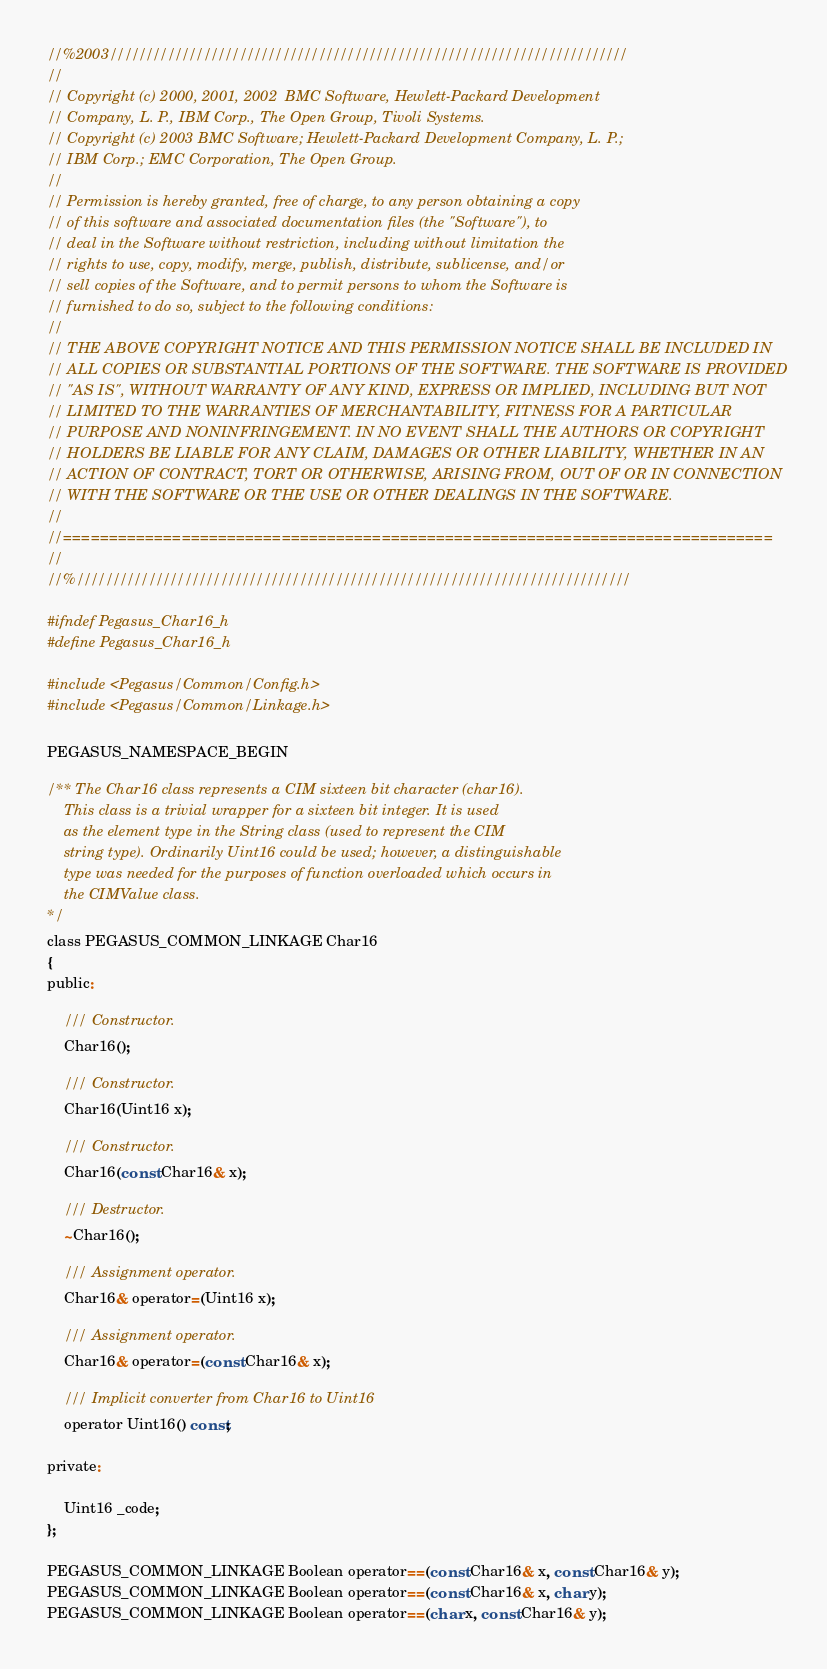Convert code to text. <code><loc_0><loc_0><loc_500><loc_500><_C_>//%2003////////////////////////////////////////////////////////////////////////
//
// Copyright (c) 2000, 2001, 2002  BMC Software, Hewlett-Packard Development
// Company, L. P., IBM Corp., The Open Group, Tivoli Systems.
// Copyright (c) 2003 BMC Software; Hewlett-Packard Development Company, L. P.;
// IBM Corp.; EMC Corporation, The Open Group.
//
// Permission is hereby granted, free of charge, to any person obtaining a copy
// of this software and associated documentation files (the "Software"), to
// deal in the Software without restriction, including without limitation the
// rights to use, copy, modify, merge, publish, distribute, sublicense, and/or
// sell copies of the Software, and to permit persons to whom the Software is
// furnished to do so, subject to the following conditions:
// 
// THE ABOVE COPYRIGHT NOTICE AND THIS PERMISSION NOTICE SHALL BE INCLUDED IN
// ALL COPIES OR SUBSTANTIAL PORTIONS OF THE SOFTWARE. THE SOFTWARE IS PROVIDED
// "AS IS", WITHOUT WARRANTY OF ANY KIND, EXPRESS OR IMPLIED, INCLUDING BUT NOT
// LIMITED TO THE WARRANTIES OF MERCHANTABILITY, FITNESS FOR A PARTICULAR
// PURPOSE AND NONINFRINGEMENT. IN NO EVENT SHALL THE AUTHORS OR COPYRIGHT
// HOLDERS BE LIABLE FOR ANY CLAIM, DAMAGES OR OTHER LIABILITY, WHETHER IN AN
// ACTION OF CONTRACT, TORT OR OTHERWISE, ARISING FROM, OUT OF OR IN CONNECTION
// WITH THE SOFTWARE OR THE USE OR OTHER DEALINGS IN THE SOFTWARE.
//
//==============================================================================
//
//%/////////////////////////////////////////////////////////////////////////////

#ifndef Pegasus_Char16_h
#define Pegasus_Char16_h

#include <Pegasus/Common/Config.h>
#include <Pegasus/Common/Linkage.h>

PEGASUS_NAMESPACE_BEGIN

/** The Char16 class represents a CIM sixteen bit character (char16).
    This class is a trivial wrapper for a sixteen bit integer. It is used
    as the element type in the String class (used to represent the CIM
    string type). Ordinarily Uint16 could be used; however, a distinguishable
    type was needed for the purposes of function overloaded which occurs in
    the CIMValue class.
*/
class PEGASUS_COMMON_LINKAGE Char16 
{
public:

    /// Constructor.
    Char16();

    /// Constructor.
    Char16(Uint16 x);

    /// Constructor.
    Char16(const Char16& x);

    /// Destructor.
    ~Char16();

    /// Assignment operator.
    Char16& operator=(Uint16 x);

    /// Assignment operator.
    Char16& operator=(const Char16& x);

    /// Implicit converter from Char16 to Uint16
    operator Uint16() const;

private:

    Uint16 _code;
};

PEGASUS_COMMON_LINKAGE Boolean operator==(const Char16& x, const Char16& y);
PEGASUS_COMMON_LINKAGE Boolean operator==(const Char16& x, char y);
PEGASUS_COMMON_LINKAGE Boolean operator==(char x, const Char16& y);</code> 